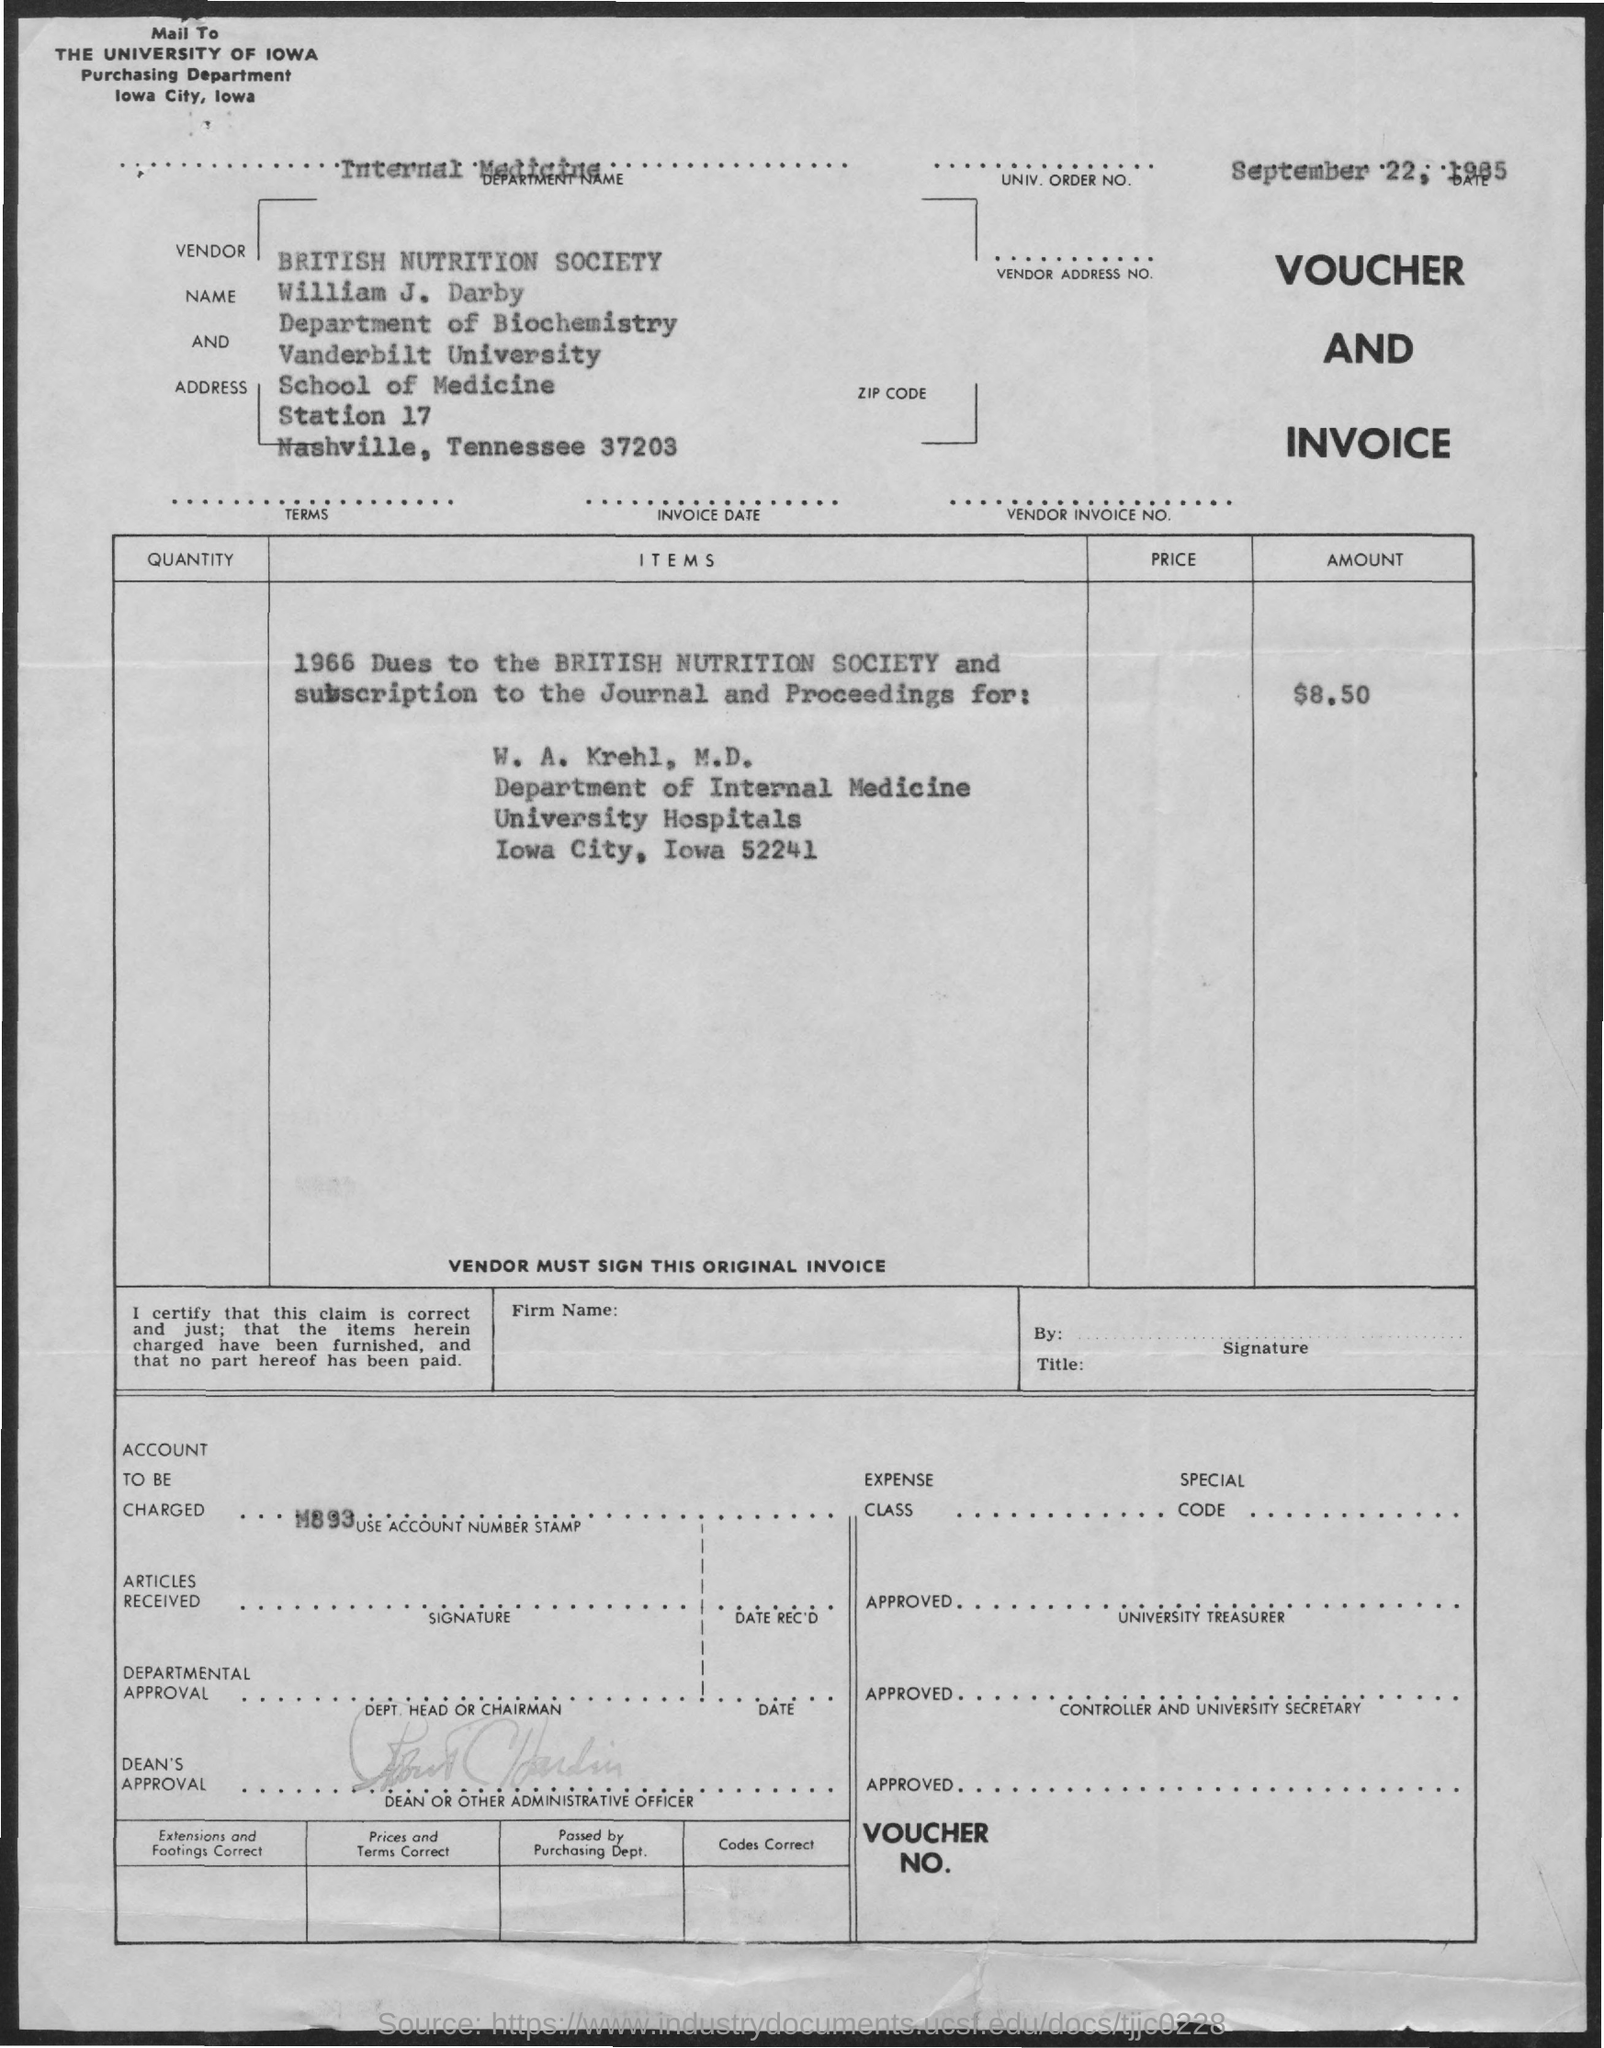Which is the account to be charged given in the voucher?
Ensure brevity in your answer.  M893. What is the deapartment name mentioned in the invoice?
Give a very brief answer. INTERNAL MEDICINE. What is the invoice amount as per the document?
Your answer should be compact. $8.50. 